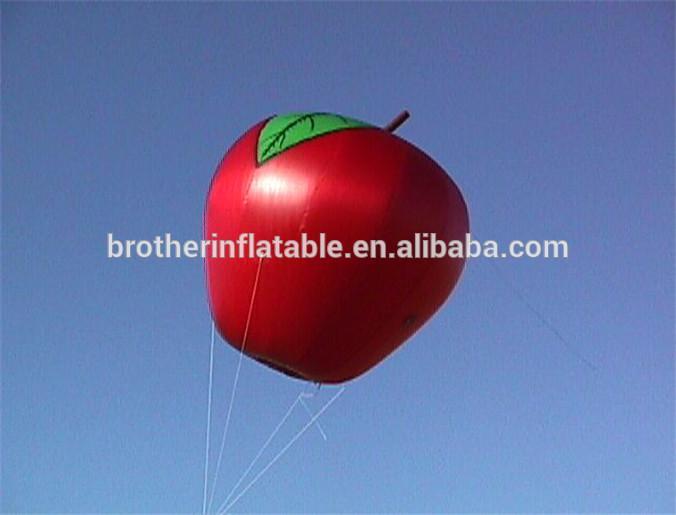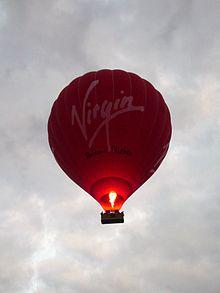The first image is the image on the left, the second image is the image on the right. Analyze the images presented: Is the assertion "The left image balloon is supposed to look like a red apple." valid? Answer yes or no. Yes. The first image is the image on the left, the second image is the image on the right. Examine the images to the left and right. Is the description "One hot air balloon is on the ground and one is in the air." accurate? Answer yes or no. No. 